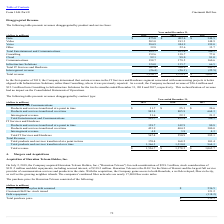According to Cincinnati Bell's financial document, What is the reclassified amount made by the company from  Consulting to Infrastructure Solutions for the twelve months ended December 31, 2018? According to the financial document, $26.6 (in millions). The relevant text states: "ted. As a result, the Company reclassed revenue of $26.6 million and $12.3 million from Consulting to Infrastructure Solutions for the twelve months ended De..." Also, What is the reclassified amount made by the company from  Consulting to Infrastructure Solutions for the twelve months ended December 31, 2019? According to the financial document, $12.3 (in millions). The relevant text states: "the Company reclassed revenue of $26.6 million and $12.3 million from Consulting to Infrastructure Solutions for the twelve months ended December 31, 2018 an..." Also, What is the revenue from total entertainment and communications in 2019? According to the financial document, 995.7 (in millions). The relevant text states: "Total Entertainment and Communications 995.7 853.4 706.1..." Also, can you calculate: What is the total revenue between 2017 to 2019? Based on the calculation: 1,536.7+1,378.2+1,065.7, the result is 3980.6 (in millions). This is based on the information: "Total revenue $ 1,536.7 $ 1,378.2 $ 1,065.7 Total revenue $ 1,536.7 $ 1,378.2 $ 1,065.7 Total revenue $ 1,536.7 $ 1,378.2 $ 1,065.7..." The key data points involved are: 1,065.7, 1,378.2, 1,536.7. Also, can you calculate: What is the total IT services and hardware between 2017 to 2019? Based on the calculation: 567.4+550.9+385.1, the result is 1503.4 (in millions). This is based on the information: "Total IT Services and Hardware 567.4 550.9 385.1 Total IT Services and Hardware 567.4 550.9 385.1 Total IT Services and Hardware 567.4 550.9 385.1..." The key data points involved are: 385.1, 550.9, 567.4. Also, can you calculate: What proportion of the 2019 total revenue is earned from total IT services and hardware? Based on the calculation: 567.4/1,536.7, the result is 36.92 (percentage). This is based on the information: "Total IT Services and Hardware 567.4 550.9 385.1 Total revenue $ 1,536.7 $ 1,378.2 $ 1,065.7..." The key data points involved are: 1,536.7, 567.4. 